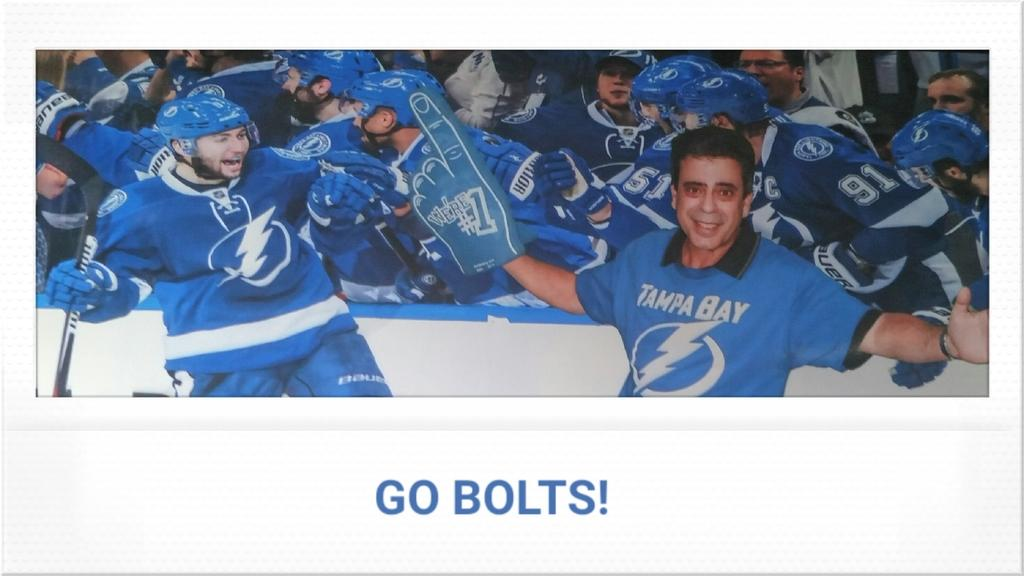<image>
Write a terse but informative summary of the picture. A wide poster of men in sports shirts with the text go bolts on the bottom. 